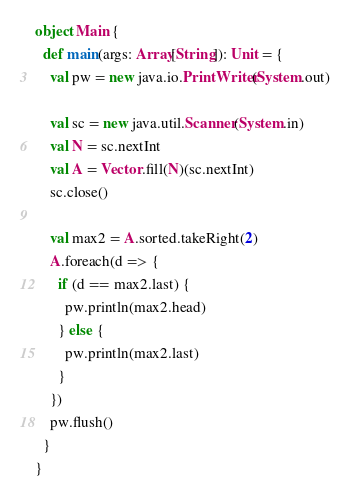Convert code to text. <code><loc_0><loc_0><loc_500><loc_500><_Scala_>object Main {
  def main(args: Array[String]): Unit = {
    val pw = new java.io.PrintWriter(System.out)

    val sc = new java.util.Scanner(System.in)
    val N = sc.nextInt
    val A = Vector.fill(N)(sc.nextInt)
    sc.close()

    val max2 = A.sorted.takeRight(2)
    A.foreach(d => {
      if (d == max2.last) {
        pw.println(max2.head)
      } else {
        pw.println(max2.last)
      }
    })
    pw.flush()
  }
}</code> 